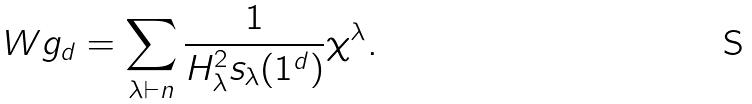<formula> <loc_0><loc_0><loc_500><loc_500>\ W g _ { d } = \sum _ { \lambda \vdash n } \frac { 1 } { H _ { \lambda } ^ { 2 } s _ { \lambda } ( 1 ^ { d } ) } \chi ^ { \lambda } .</formula> 